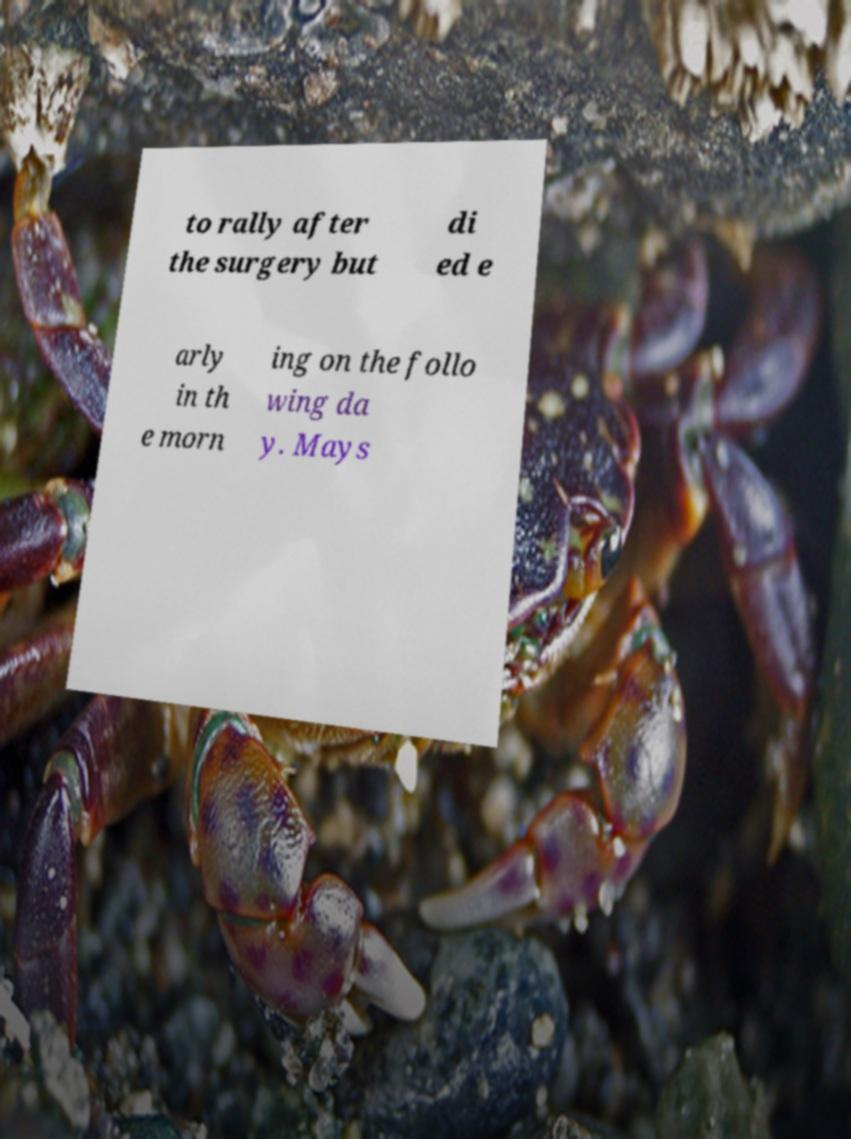Can you accurately transcribe the text from the provided image for me? to rally after the surgery but di ed e arly in th e morn ing on the follo wing da y. Mays 